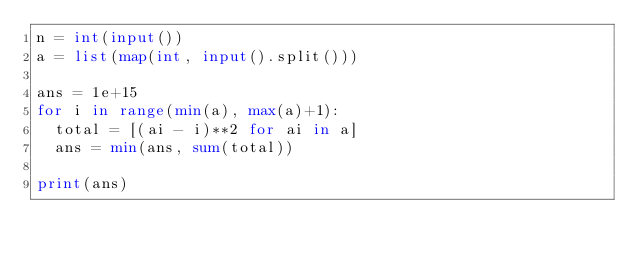Convert code to text. <code><loc_0><loc_0><loc_500><loc_500><_Python_>n = int(input())
a = list(map(int, input().split()))

ans = 1e+15
for i in range(min(a), max(a)+1):
  total = [(ai - i)**2 for ai in a]
  ans = min(ans, sum(total))
  
print(ans)</code> 